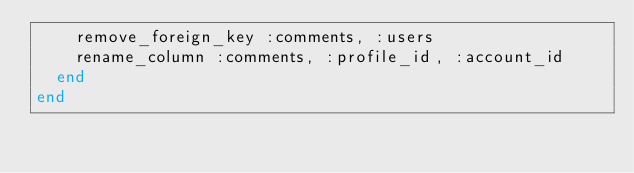<code> <loc_0><loc_0><loc_500><loc_500><_Ruby_>    remove_foreign_key :comments, :users
    rename_column :comments, :profile_id, :account_id
  end
end
</code> 